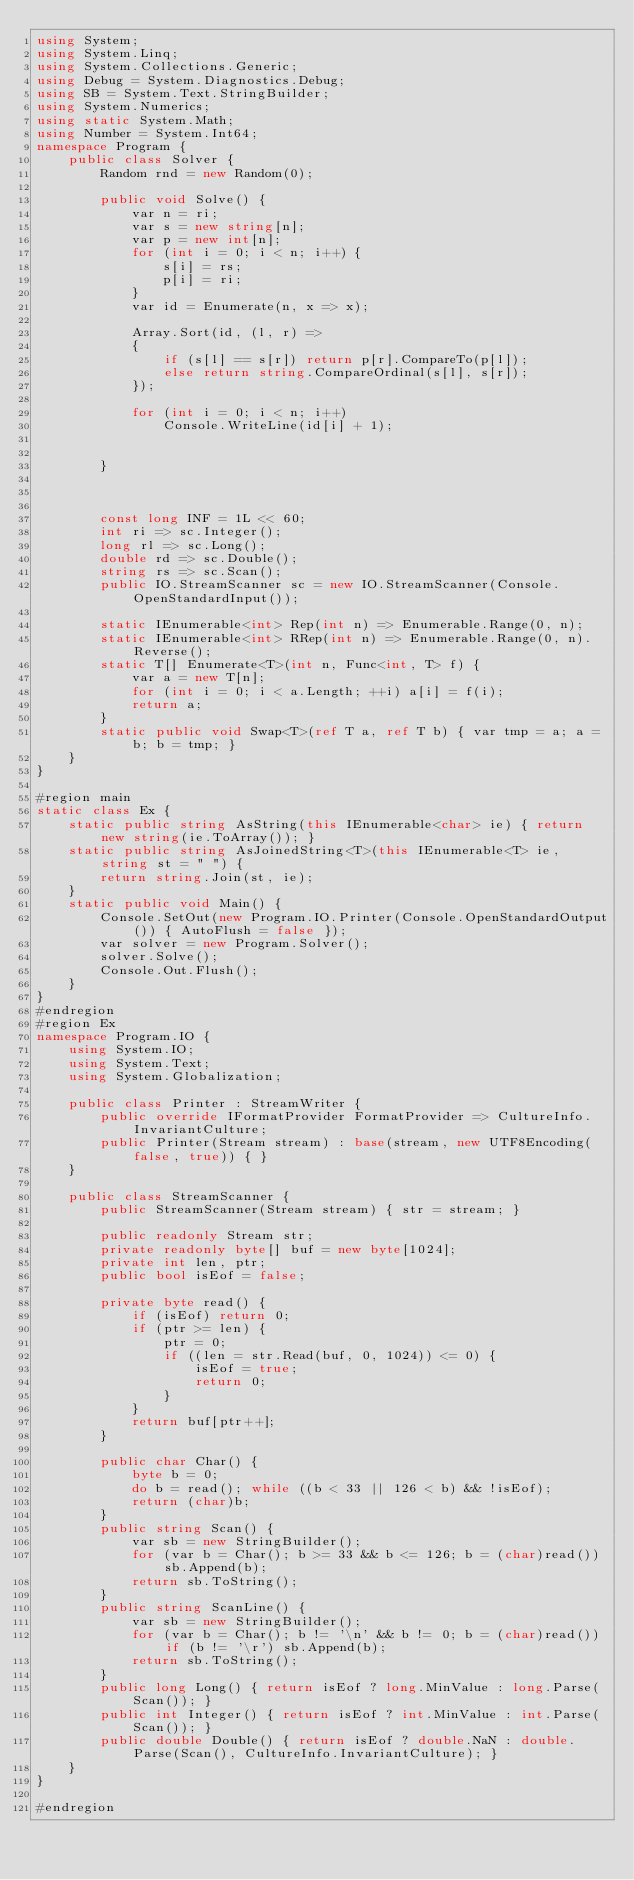Convert code to text. <code><loc_0><loc_0><loc_500><loc_500><_C#_>using System;
using System.Linq;
using System.Collections.Generic;
using Debug = System.Diagnostics.Debug;
using SB = System.Text.StringBuilder;
using System.Numerics;
using static System.Math;
using Number = System.Int64;
namespace Program {
    public class Solver {
        Random rnd = new Random(0);

        public void Solve() {
            var n = ri;
            var s = new string[n];
            var p = new int[n];
            for (int i = 0; i < n; i++) {
                s[i] = rs;
                p[i] = ri;
            }
            var id = Enumerate(n, x => x);

            Array.Sort(id, (l, r) =>
            {
                if (s[l] == s[r]) return p[r].CompareTo(p[l]);
                else return string.CompareOrdinal(s[l], s[r]);
            });

            for (int i = 0; i < n; i++)
                Console.WriteLine(id[i] + 1);


        }



        const long INF = 1L << 60;
        int ri => sc.Integer();
        long rl => sc.Long();
        double rd => sc.Double();
        string rs => sc.Scan();
        public IO.StreamScanner sc = new IO.StreamScanner(Console.OpenStandardInput());

        static IEnumerable<int> Rep(int n) => Enumerable.Range(0, n);
        static IEnumerable<int> RRep(int n) => Enumerable.Range(0, n).Reverse();
        static T[] Enumerate<T>(int n, Func<int, T> f) {
            var a = new T[n];
            for (int i = 0; i < a.Length; ++i) a[i] = f(i);
            return a;
        }
        static public void Swap<T>(ref T a, ref T b) { var tmp = a; a = b; b = tmp; }
    }
}

#region main
static class Ex {
    static public string AsString(this IEnumerable<char> ie) { return new string(ie.ToArray()); }
    static public string AsJoinedString<T>(this IEnumerable<T> ie, string st = " ") {
        return string.Join(st, ie);
    }
    static public void Main() {
        Console.SetOut(new Program.IO.Printer(Console.OpenStandardOutput()) { AutoFlush = false });
        var solver = new Program.Solver();
        solver.Solve();
        Console.Out.Flush();
    }
}
#endregion
#region Ex
namespace Program.IO {
    using System.IO;
    using System.Text;
    using System.Globalization;

    public class Printer : StreamWriter {
        public override IFormatProvider FormatProvider => CultureInfo.InvariantCulture;
        public Printer(Stream stream) : base(stream, new UTF8Encoding(false, true)) { }
    }

    public class StreamScanner {
        public StreamScanner(Stream stream) { str = stream; }

        public readonly Stream str;
        private readonly byte[] buf = new byte[1024];
        private int len, ptr;
        public bool isEof = false;

        private byte read() {
            if (isEof) return 0;
            if (ptr >= len) {
                ptr = 0;
                if ((len = str.Read(buf, 0, 1024)) <= 0) {
                    isEof = true;
                    return 0;
                }
            }
            return buf[ptr++];
        }

        public char Char() {
            byte b = 0;
            do b = read(); while ((b < 33 || 126 < b) && !isEof);
            return (char)b;
        }
        public string Scan() {
            var sb = new StringBuilder();
            for (var b = Char(); b >= 33 && b <= 126; b = (char)read()) sb.Append(b);
            return sb.ToString();
        }
        public string ScanLine() {
            var sb = new StringBuilder();
            for (var b = Char(); b != '\n' && b != 0; b = (char)read()) if (b != '\r') sb.Append(b);
            return sb.ToString();
        }
        public long Long() { return isEof ? long.MinValue : long.Parse(Scan()); }
        public int Integer() { return isEof ? int.MinValue : int.Parse(Scan()); }
        public double Double() { return isEof ? double.NaN : double.Parse(Scan(), CultureInfo.InvariantCulture); }
    }
}

#endregion

</code> 